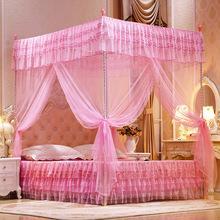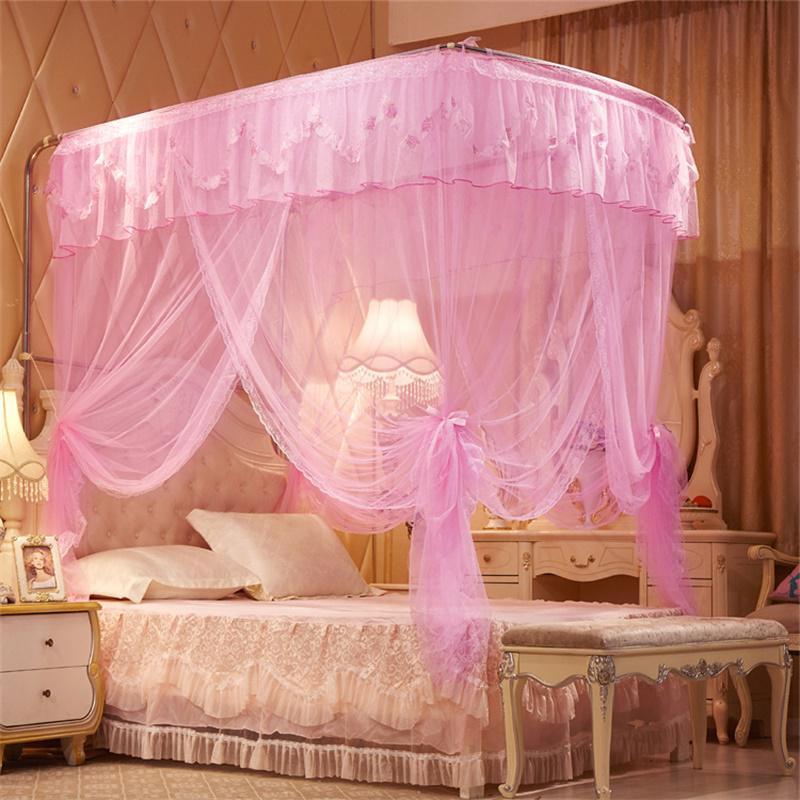The first image is the image on the left, the second image is the image on the right. Analyze the images presented: Is the assertion "The canopy on the right is a purple or lavender shade, while the canopy on the left is clearly pink." valid? Answer yes or no. No. The first image is the image on the left, the second image is the image on the right. Given the left and right images, does the statement "The image on the right contains a bed set with a purple net canopy." hold true? Answer yes or no. No. 